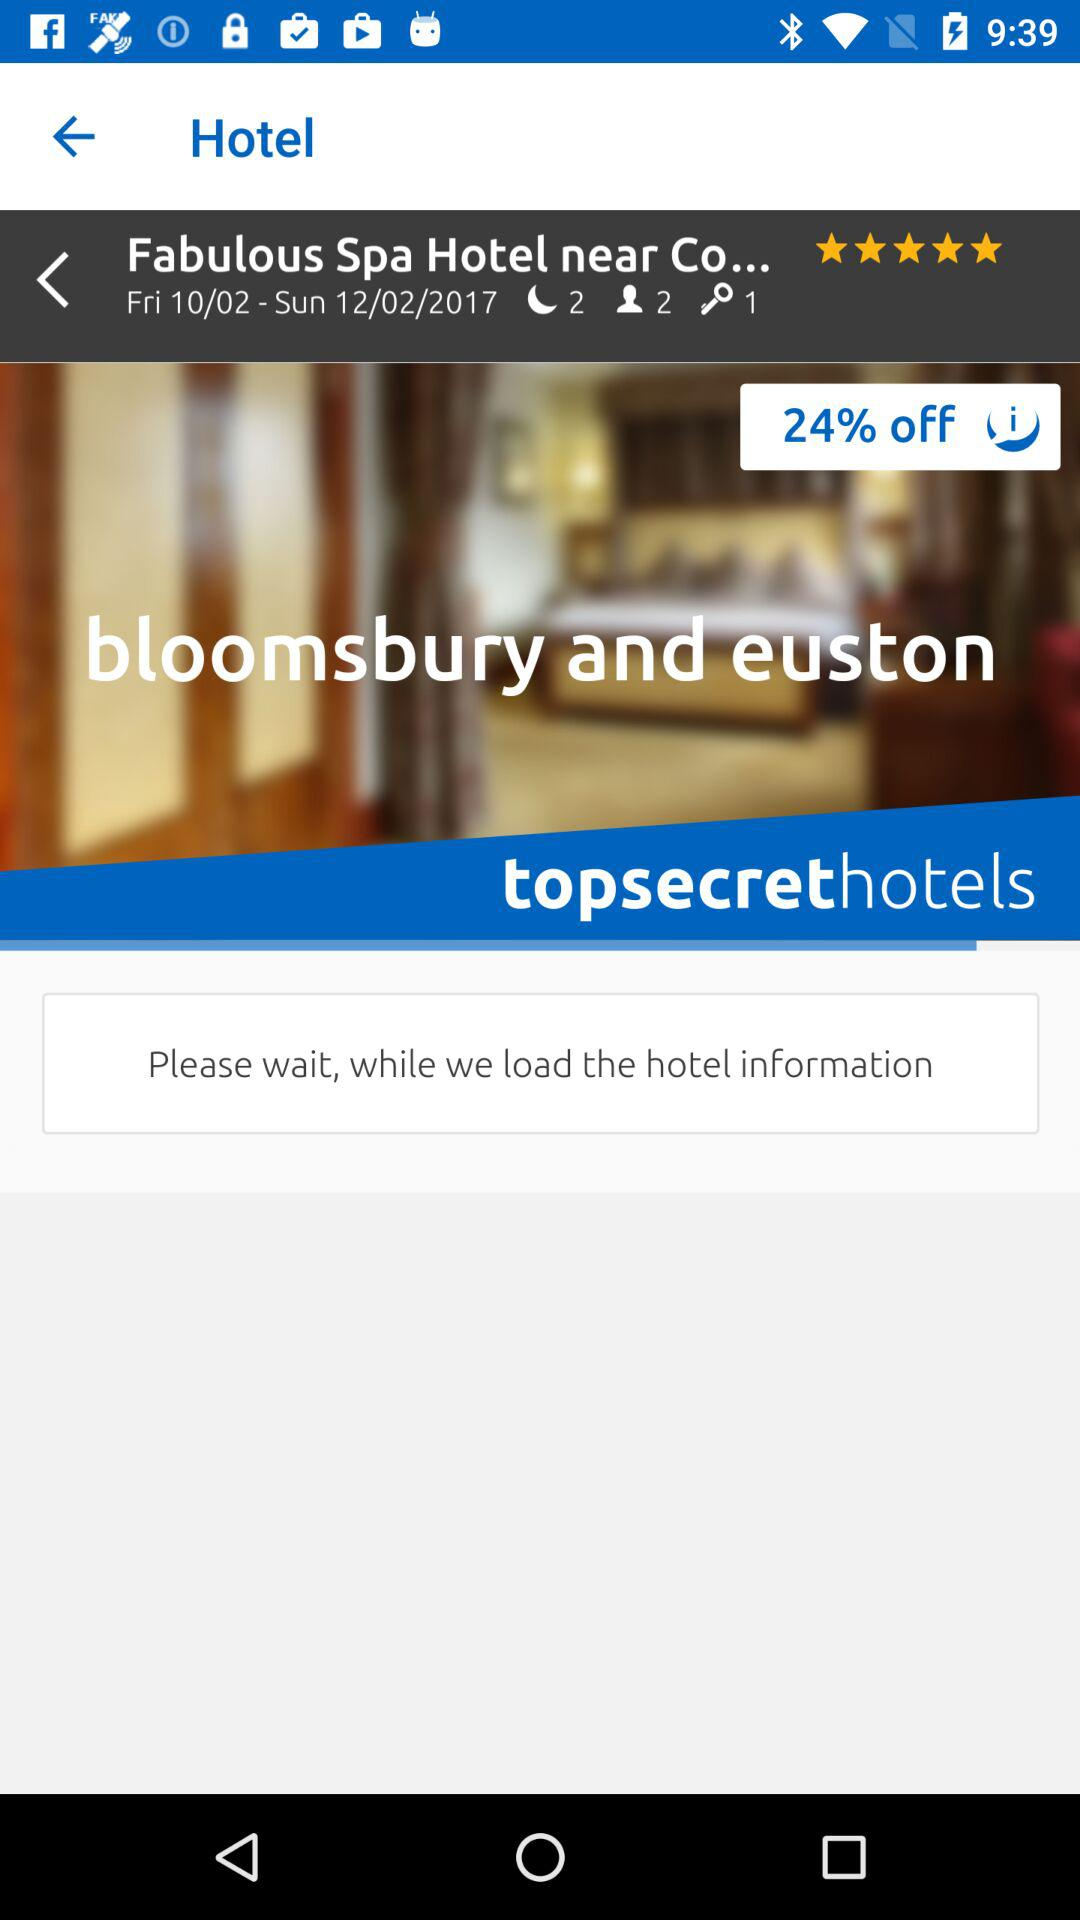How many days is the stay?
Answer the question using a single word or phrase. 2 